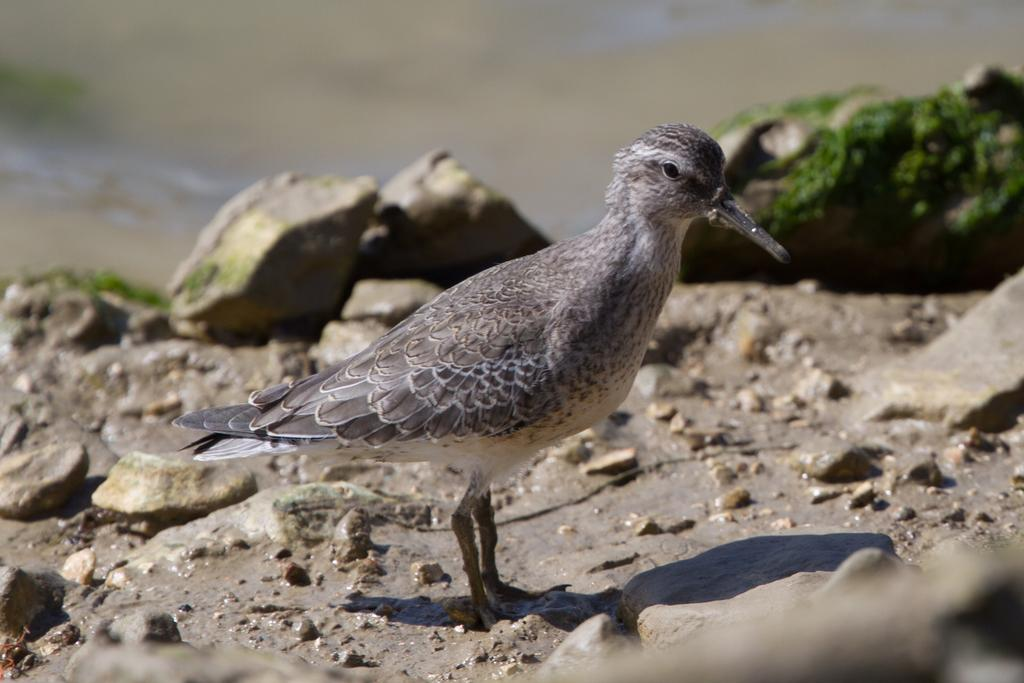What type of animal can be seen in the image? There is a bird in the image. Where is the bird located in the image? The bird is standing on the ground. What other objects can be seen in the image? There are stones visible in the image. Can you describe the quality of the image? The top part of the image is blurry. What story is the bird telling in the image? There is no indication in the image that the bird is telling a story, as birds do not communicate through stories. 